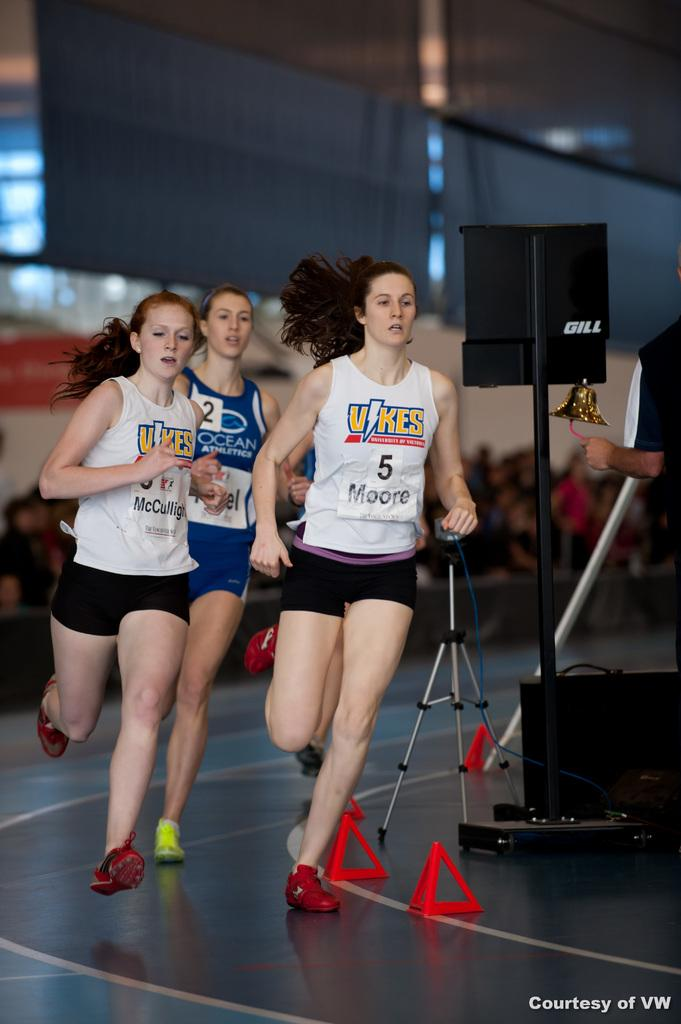<image>
Render a clear and concise summary of the photo. Female runners are wearing jerseys with the name Vikes on them. 